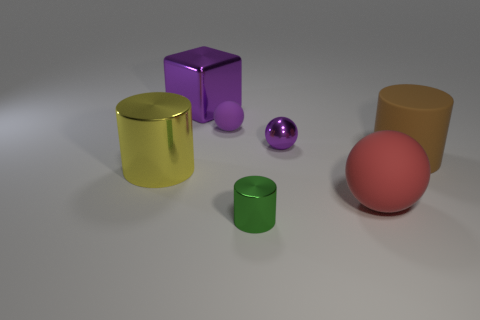Add 3 large purple blocks. How many objects exist? 10 Subtract all spheres. How many objects are left? 4 Subtract all small yellow things. Subtract all tiny purple metallic spheres. How many objects are left? 6 Add 1 brown cylinders. How many brown cylinders are left? 2 Add 4 big gray rubber cylinders. How many big gray rubber cylinders exist? 4 Subtract 0 red blocks. How many objects are left? 7 